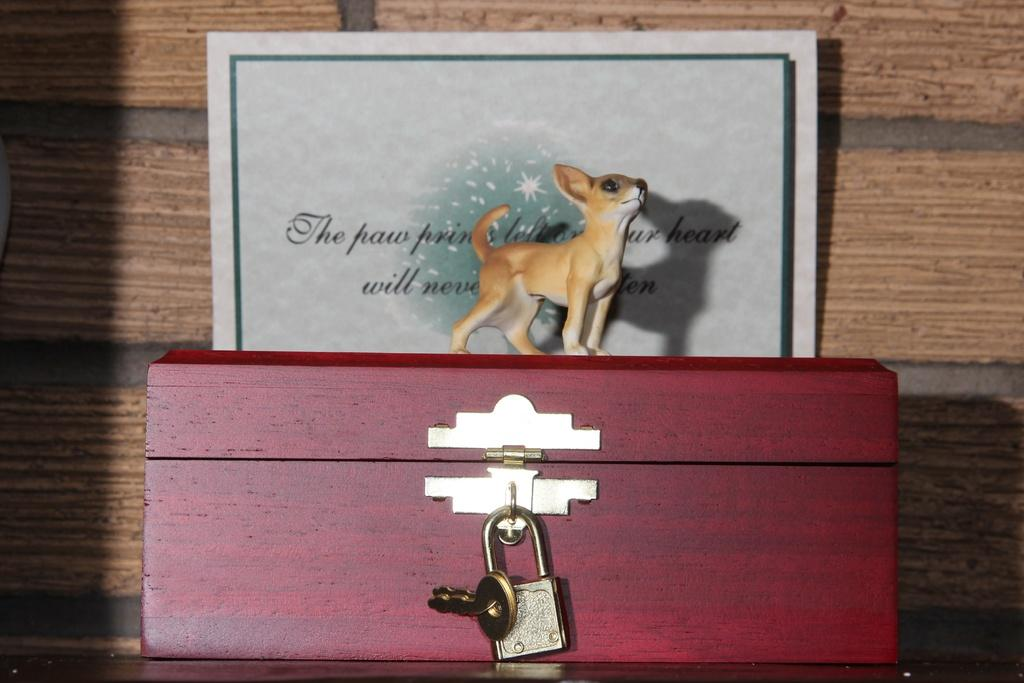What object can be seen in the image? There is a toy in the image. What is the toy placed in front of? The toy is in front of a card. Where is the card located? The card is on a box. What is the status of the box? The box is locked. Can you see any worms crawling on the toy in the image? There are no worms present in the image. 